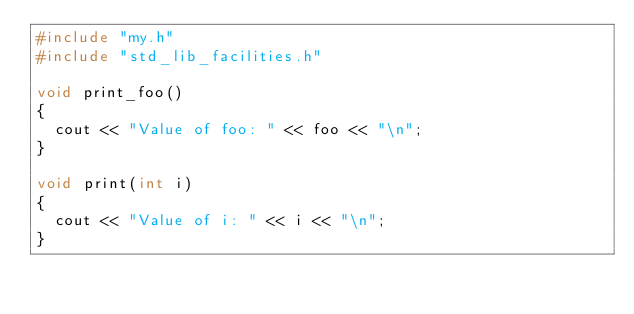Convert code to text. <code><loc_0><loc_0><loc_500><loc_500><_C++_>#include "my.h"
#include "std_lib_facilities.h"

void print_foo()
{
	cout << "Value of foo: " << foo << "\n";
}

void print(int i)
{
	cout << "Value of i: " << i << "\n";
}</code> 